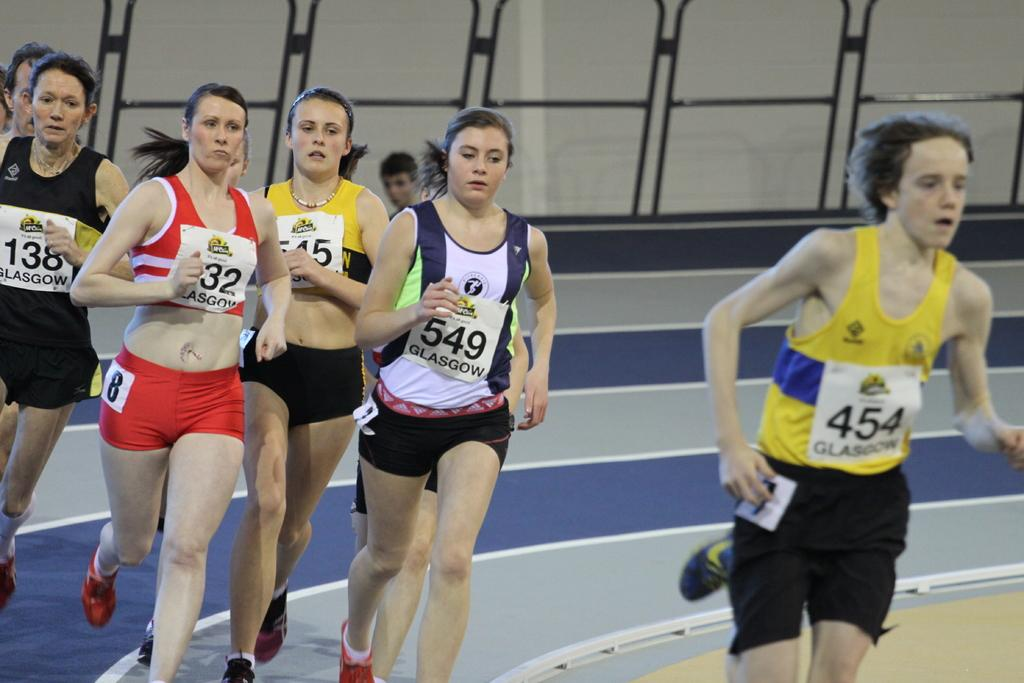<image>
Present a compact description of the photo's key features. The track stars are being led by number 454 as they come around the bend. 